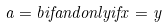Convert formula to latex. <formula><loc_0><loc_0><loc_500><loc_500>a = b i f a n d o n l y i f x = y</formula> 